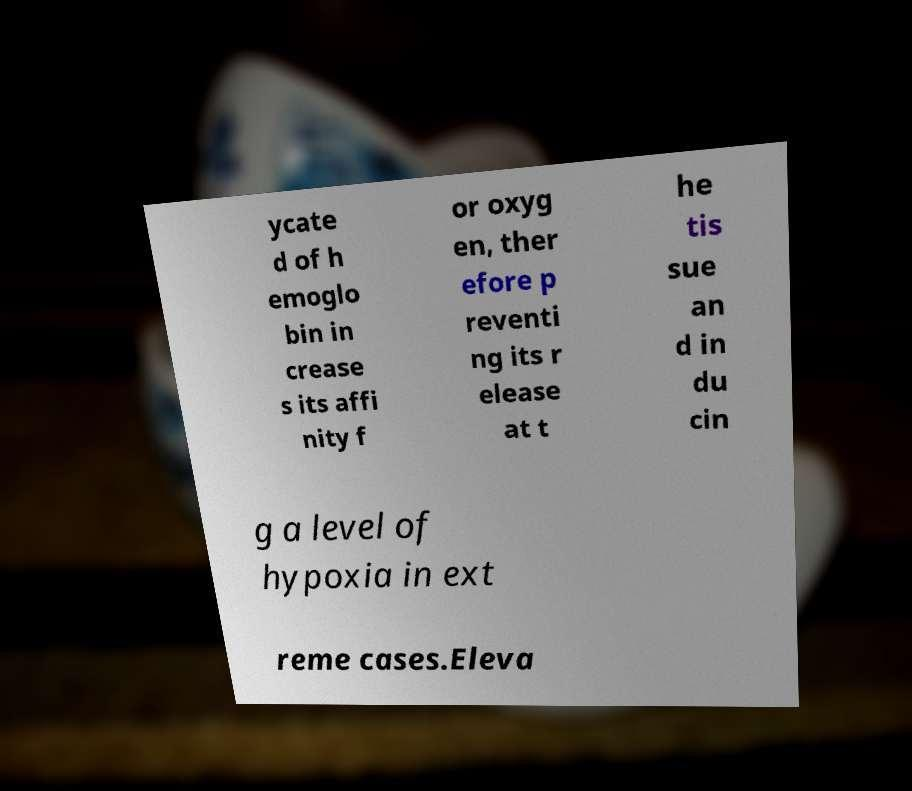There's text embedded in this image that I need extracted. Can you transcribe it verbatim? ycate d of h emoglo bin in crease s its affi nity f or oxyg en, ther efore p reventi ng its r elease at t he tis sue an d in du cin g a level of hypoxia in ext reme cases.Eleva 